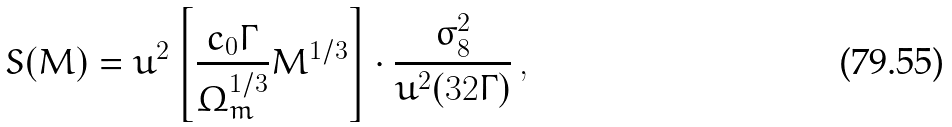Convert formula to latex. <formula><loc_0><loc_0><loc_500><loc_500>S ( M ) = u ^ { 2 } \left [ \frac { c _ { 0 } \Gamma } { \Omega _ { m } ^ { 1 / 3 } } M ^ { 1 / 3 } \right ] \cdot \frac { \sigma _ { 8 } ^ { 2 } } { u ^ { 2 } ( 3 2 \Gamma ) } \, ,</formula> 